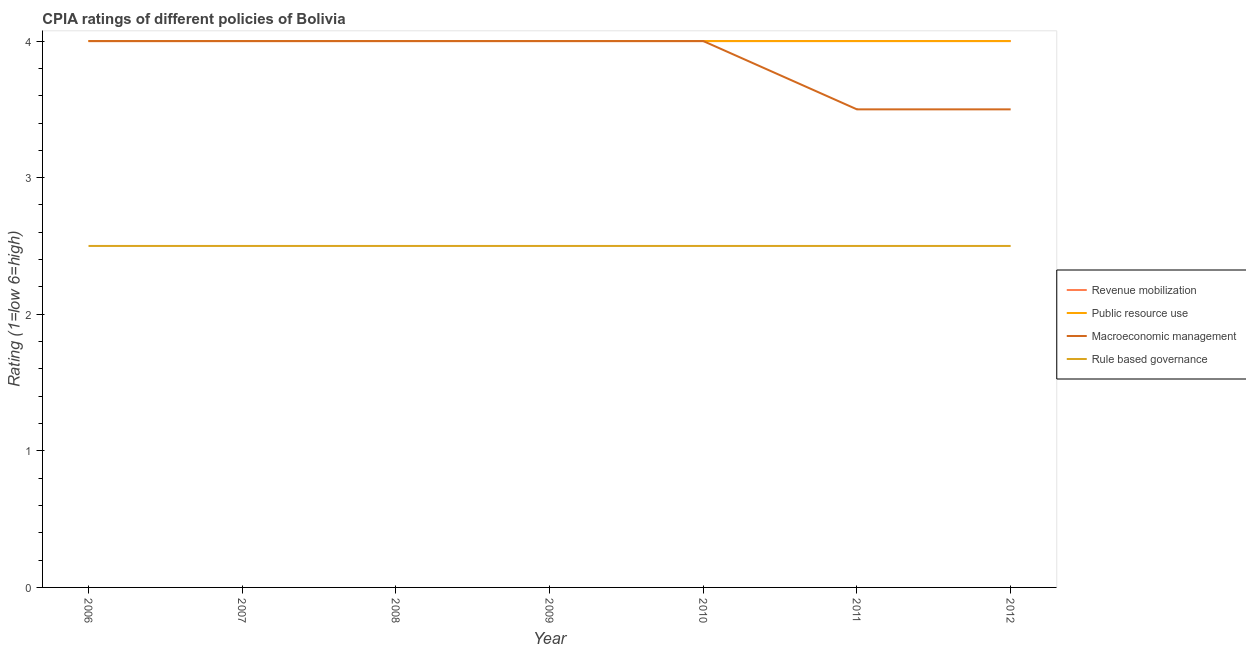How many different coloured lines are there?
Make the answer very short. 4. Is the number of lines equal to the number of legend labels?
Offer a terse response. Yes. Across all years, what is the maximum cpia rating of macroeconomic management?
Your answer should be very brief. 4. Across all years, what is the minimum cpia rating of public resource use?
Your response must be concise. 4. In which year was the cpia rating of public resource use maximum?
Provide a short and direct response. 2006. What is the average cpia rating of rule based governance per year?
Give a very brief answer. 2.5. What is the ratio of the cpia rating of macroeconomic management in 2010 to that in 2011?
Ensure brevity in your answer.  1.14. What is the difference between the highest and the second highest cpia rating of public resource use?
Your answer should be compact. 0. What is the difference between the highest and the lowest cpia rating of rule based governance?
Your response must be concise. 0. In how many years, is the cpia rating of public resource use greater than the average cpia rating of public resource use taken over all years?
Offer a very short reply. 0. Is the sum of the cpia rating of public resource use in 2009 and 2010 greater than the maximum cpia rating of rule based governance across all years?
Provide a succinct answer. Yes. Is it the case that in every year, the sum of the cpia rating of public resource use and cpia rating of macroeconomic management is greater than the sum of cpia rating of rule based governance and cpia rating of revenue mobilization?
Provide a succinct answer. No. Is the cpia rating of rule based governance strictly less than the cpia rating of public resource use over the years?
Your answer should be very brief. Yes. How many lines are there?
Offer a very short reply. 4. What is the difference between two consecutive major ticks on the Y-axis?
Your answer should be compact. 1. Does the graph contain any zero values?
Provide a short and direct response. No. How many legend labels are there?
Ensure brevity in your answer.  4. How are the legend labels stacked?
Keep it short and to the point. Vertical. What is the title of the graph?
Ensure brevity in your answer.  CPIA ratings of different policies of Bolivia. Does "Water" appear as one of the legend labels in the graph?
Provide a succinct answer. No. What is the label or title of the Y-axis?
Provide a short and direct response. Rating (1=low 6=high). What is the Rating (1=low 6=high) of Public resource use in 2006?
Make the answer very short. 4. What is the Rating (1=low 6=high) in Rule based governance in 2006?
Provide a short and direct response. 2.5. What is the Rating (1=low 6=high) of Revenue mobilization in 2007?
Provide a succinct answer. 4. What is the Rating (1=low 6=high) of Macroeconomic management in 2007?
Offer a very short reply. 4. What is the Rating (1=low 6=high) in Public resource use in 2008?
Ensure brevity in your answer.  4. What is the Rating (1=low 6=high) in Macroeconomic management in 2008?
Provide a succinct answer. 4. What is the Rating (1=low 6=high) of Revenue mobilization in 2009?
Your answer should be very brief. 4. What is the Rating (1=low 6=high) of Public resource use in 2009?
Provide a short and direct response. 4. What is the Rating (1=low 6=high) in Macroeconomic management in 2011?
Your response must be concise. 3.5. What is the Rating (1=low 6=high) in Rule based governance in 2011?
Your response must be concise. 2.5. What is the Rating (1=low 6=high) of Revenue mobilization in 2012?
Provide a succinct answer. 4. What is the Rating (1=low 6=high) of Rule based governance in 2012?
Provide a succinct answer. 2.5. Across all years, what is the maximum Rating (1=low 6=high) in Macroeconomic management?
Provide a short and direct response. 4. Across all years, what is the minimum Rating (1=low 6=high) of Revenue mobilization?
Offer a very short reply. 4. Across all years, what is the minimum Rating (1=low 6=high) in Public resource use?
Make the answer very short. 4. Across all years, what is the minimum Rating (1=low 6=high) in Macroeconomic management?
Keep it short and to the point. 3.5. What is the total Rating (1=low 6=high) of Macroeconomic management in the graph?
Your answer should be very brief. 27. What is the total Rating (1=low 6=high) of Rule based governance in the graph?
Provide a succinct answer. 17.5. What is the difference between the Rating (1=low 6=high) in Revenue mobilization in 2006 and that in 2007?
Ensure brevity in your answer.  0. What is the difference between the Rating (1=low 6=high) of Public resource use in 2006 and that in 2007?
Your answer should be very brief. 0. What is the difference between the Rating (1=low 6=high) in Macroeconomic management in 2006 and that in 2007?
Provide a succinct answer. 0. What is the difference between the Rating (1=low 6=high) in Revenue mobilization in 2006 and that in 2008?
Provide a succinct answer. 0. What is the difference between the Rating (1=low 6=high) in Rule based governance in 2006 and that in 2008?
Provide a short and direct response. 0. What is the difference between the Rating (1=low 6=high) in Rule based governance in 2006 and that in 2009?
Keep it short and to the point. 0. What is the difference between the Rating (1=low 6=high) in Macroeconomic management in 2006 and that in 2010?
Your answer should be compact. 0. What is the difference between the Rating (1=low 6=high) in Rule based governance in 2006 and that in 2010?
Your response must be concise. 0. What is the difference between the Rating (1=low 6=high) in Revenue mobilization in 2006 and that in 2011?
Your answer should be very brief. 0. What is the difference between the Rating (1=low 6=high) of Public resource use in 2006 and that in 2011?
Provide a succinct answer. 0. What is the difference between the Rating (1=low 6=high) in Macroeconomic management in 2006 and that in 2011?
Your answer should be compact. 0.5. What is the difference between the Rating (1=low 6=high) of Rule based governance in 2006 and that in 2011?
Give a very brief answer. 0. What is the difference between the Rating (1=low 6=high) in Revenue mobilization in 2006 and that in 2012?
Keep it short and to the point. 0. What is the difference between the Rating (1=low 6=high) of Public resource use in 2006 and that in 2012?
Your answer should be compact. 0. What is the difference between the Rating (1=low 6=high) in Macroeconomic management in 2006 and that in 2012?
Make the answer very short. 0.5. What is the difference between the Rating (1=low 6=high) of Macroeconomic management in 2007 and that in 2008?
Make the answer very short. 0. What is the difference between the Rating (1=low 6=high) of Macroeconomic management in 2007 and that in 2009?
Your response must be concise. 0. What is the difference between the Rating (1=low 6=high) in Revenue mobilization in 2007 and that in 2010?
Make the answer very short. 0. What is the difference between the Rating (1=low 6=high) in Rule based governance in 2007 and that in 2010?
Provide a short and direct response. 0. What is the difference between the Rating (1=low 6=high) in Revenue mobilization in 2007 and that in 2011?
Ensure brevity in your answer.  0. What is the difference between the Rating (1=low 6=high) of Public resource use in 2007 and that in 2011?
Provide a succinct answer. 0. What is the difference between the Rating (1=low 6=high) in Revenue mobilization in 2007 and that in 2012?
Make the answer very short. 0. What is the difference between the Rating (1=low 6=high) of Macroeconomic management in 2007 and that in 2012?
Provide a succinct answer. 0.5. What is the difference between the Rating (1=low 6=high) of Rule based governance in 2007 and that in 2012?
Provide a succinct answer. 0. What is the difference between the Rating (1=low 6=high) of Revenue mobilization in 2008 and that in 2009?
Your answer should be very brief. 0. What is the difference between the Rating (1=low 6=high) of Macroeconomic management in 2008 and that in 2009?
Keep it short and to the point. 0. What is the difference between the Rating (1=low 6=high) of Rule based governance in 2008 and that in 2009?
Give a very brief answer. 0. What is the difference between the Rating (1=low 6=high) in Macroeconomic management in 2008 and that in 2010?
Your response must be concise. 0. What is the difference between the Rating (1=low 6=high) in Rule based governance in 2008 and that in 2010?
Give a very brief answer. 0. What is the difference between the Rating (1=low 6=high) in Revenue mobilization in 2008 and that in 2011?
Provide a succinct answer. 0. What is the difference between the Rating (1=low 6=high) of Public resource use in 2008 and that in 2011?
Offer a terse response. 0. What is the difference between the Rating (1=low 6=high) in Macroeconomic management in 2008 and that in 2011?
Your answer should be compact. 0.5. What is the difference between the Rating (1=low 6=high) of Rule based governance in 2008 and that in 2011?
Make the answer very short. 0. What is the difference between the Rating (1=low 6=high) in Revenue mobilization in 2008 and that in 2012?
Give a very brief answer. 0. What is the difference between the Rating (1=low 6=high) in Public resource use in 2008 and that in 2012?
Make the answer very short. 0. What is the difference between the Rating (1=low 6=high) in Macroeconomic management in 2008 and that in 2012?
Your response must be concise. 0.5. What is the difference between the Rating (1=low 6=high) of Macroeconomic management in 2009 and that in 2010?
Provide a short and direct response. 0. What is the difference between the Rating (1=low 6=high) in Rule based governance in 2009 and that in 2010?
Provide a short and direct response. 0. What is the difference between the Rating (1=low 6=high) of Revenue mobilization in 2009 and that in 2011?
Your answer should be compact. 0. What is the difference between the Rating (1=low 6=high) in Macroeconomic management in 2009 and that in 2011?
Your answer should be compact. 0.5. What is the difference between the Rating (1=low 6=high) of Rule based governance in 2009 and that in 2011?
Your answer should be very brief. 0. What is the difference between the Rating (1=low 6=high) in Revenue mobilization in 2009 and that in 2012?
Ensure brevity in your answer.  0. What is the difference between the Rating (1=low 6=high) in Macroeconomic management in 2009 and that in 2012?
Offer a terse response. 0.5. What is the difference between the Rating (1=low 6=high) of Rule based governance in 2009 and that in 2012?
Offer a very short reply. 0. What is the difference between the Rating (1=low 6=high) of Macroeconomic management in 2010 and that in 2011?
Provide a succinct answer. 0.5. What is the difference between the Rating (1=low 6=high) of Macroeconomic management in 2010 and that in 2012?
Your response must be concise. 0.5. What is the difference between the Rating (1=low 6=high) in Public resource use in 2011 and that in 2012?
Offer a very short reply. 0. What is the difference between the Rating (1=low 6=high) of Rule based governance in 2011 and that in 2012?
Make the answer very short. 0. What is the difference between the Rating (1=low 6=high) of Public resource use in 2006 and the Rating (1=low 6=high) of Macroeconomic management in 2007?
Provide a succinct answer. 0. What is the difference between the Rating (1=low 6=high) in Revenue mobilization in 2006 and the Rating (1=low 6=high) in Public resource use in 2008?
Make the answer very short. 0. What is the difference between the Rating (1=low 6=high) in Revenue mobilization in 2006 and the Rating (1=low 6=high) in Macroeconomic management in 2008?
Offer a terse response. 0. What is the difference between the Rating (1=low 6=high) of Revenue mobilization in 2006 and the Rating (1=low 6=high) of Rule based governance in 2008?
Offer a very short reply. 1.5. What is the difference between the Rating (1=low 6=high) of Public resource use in 2006 and the Rating (1=low 6=high) of Macroeconomic management in 2008?
Your answer should be very brief. 0. What is the difference between the Rating (1=low 6=high) in Public resource use in 2006 and the Rating (1=low 6=high) in Rule based governance in 2008?
Make the answer very short. 1.5. What is the difference between the Rating (1=low 6=high) of Revenue mobilization in 2006 and the Rating (1=low 6=high) of Public resource use in 2009?
Offer a very short reply. 0. What is the difference between the Rating (1=low 6=high) in Revenue mobilization in 2006 and the Rating (1=low 6=high) in Rule based governance in 2009?
Your answer should be very brief. 1.5. What is the difference between the Rating (1=low 6=high) in Public resource use in 2006 and the Rating (1=low 6=high) in Rule based governance in 2009?
Provide a short and direct response. 1.5. What is the difference between the Rating (1=low 6=high) in Revenue mobilization in 2006 and the Rating (1=low 6=high) in Macroeconomic management in 2010?
Provide a short and direct response. 0. What is the difference between the Rating (1=low 6=high) of Public resource use in 2006 and the Rating (1=low 6=high) of Macroeconomic management in 2010?
Give a very brief answer. 0. What is the difference between the Rating (1=low 6=high) in Public resource use in 2006 and the Rating (1=low 6=high) in Rule based governance in 2010?
Ensure brevity in your answer.  1.5. What is the difference between the Rating (1=low 6=high) in Macroeconomic management in 2006 and the Rating (1=low 6=high) in Rule based governance in 2010?
Your answer should be very brief. 1.5. What is the difference between the Rating (1=low 6=high) in Revenue mobilization in 2006 and the Rating (1=low 6=high) in Public resource use in 2011?
Your response must be concise. 0. What is the difference between the Rating (1=low 6=high) in Revenue mobilization in 2006 and the Rating (1=low 6=high) in Rule based governance in 2011?
Offer a very short reply. 1.5. What is the difference between the Rating (1=low 6=high) in Public resource use in 2006 and the Rating (1=low 6=high) in Macroeconomic management in 2011?
Keep it short and to the point. 0.5. What is the difference between the Rating (1=low 6=high) in Macroeconomic management in 2006 and the Rating (1=low 6=high) in Rule based governance in 2011?
Provide a short and direct response. 1.5. What is the difference between the Rating (1=low 6=high) of Revenue mobilization in 2006 and the Rating (1=low 6=high) of Rule based governance in 2012?
Ensure brevity in your answer.  1.5. What is the difference between the Rating (1=low 6=high) in Public resource use in 2006 and the Rating (1=low 6=high) in Macroeconomic management in 2012?
Keep it short and to the point. 0.5. What is the difference between the Rating (1=low 6=high) of Public resource use in 2006 and the Rating (1=low 6=high) of Rule based governance in 2012?
Your response must be concise. 1.5. What is the difference between the Rating (1=low 6=high) of Revenue mobilization in 2007 and the Rating (1=low 6=high) of Public resource use in 2008?
Provide a short and direct response. 0. What is the difference between the Rating (1=low 6=high) in Revenue mobilization in 2007 and the Rating (1=low 6=high) in Macroeconomic management in 2008?
Keep it short and to the point. 0. What is the difference between the Rating (1=low 6=high) in Revenue mobilization in 2007 and the Rating (1=low 6=high) in Rule based governance in 2008?
Offer a very short reply. 1.5. What is the difference between the Rating (1=low 6=high) of Macroeconomic management in 2007 and the Rating (1=low 6=high) of Rule based governance in 2008?
Offer a very short reply. 1.5. What is the difference between the Rating (1=low 6=high) of Revenue mobilization in 2007 and the Rating (1=low 6=high) of Rule based governance in 2009?
Provide a short and direct response. 1.5. What is the difference between the Rating (1=low 6=high) in Public resource use in 2007 and the Rating (1=low 6=high) in Macroeconomic management in 2009?
Provide a succinct answer. 0. What is the difference between the Rating (1=low 6=high) of Macroeconomic management in 2007 and the Rating (1=low 6=high) of Rule based governance in 2009?
Ensure brevity in your answer.  1.5. What is the difference between the Rating (1=low 6=high) of Revenue mobilization in 2007 and the Rating (1=low 6=high) of Macroeconomic management in 2010?
Keep it short and to the point. 0. What is the difference between the Rating (1=low 6=high) in Revenue mobilization in 2007 and the Rating (1=low 6=high) in Rule based governance in 2010?
Make the answer very short. 1.5. What is the difference between the Rating (1=low 6=high) of Public resource use in 2007 and the Rating (1=low 6=high) of Macroeconomic management in 2010?
Provide a succinct answer. 0. What is the difference between the Rating (1=low 6=high) of Public resource use in 2007 and the Rating (1=low 6=high) of Rule based governance in 2010?
Provide a succinct answer. 1.5. What is the difference between the Rating (1=low 6=high) of Revenue mobilization in 2007 and the Rating (1=low 6=high) of Macroeconomic management in 2011?
Provide a short and direct response. 0.5. What is the difference between the Rating (1=low 6=high) in Public resource use in 2007 and the Rating (1=low 6=high) in Macroeconomic management in 2011?
Provide a short and direct response. 0.5. What is the difference between the Rating (1=low 6=high) in Public resource use in 2007 and the Rating (1=low 6=high) in Rule based governance in 2012?
Make the answer very short. 1.5. What is the difference between the Rating (1=low 6=high) of Revenue mobilization in 2008 and the Rating (1=low 6=high) of Public resource use in 2009?
Make the answer very short. 0. What is the difference between the Rating (1=low 6=high) of Revenue mobilization in 2008 and the Rating (1=low 6=high) of Macroeconomic management in 2009?
Your answer should be very brief. 0. What is the difference between the Rating (1=low 6=high) in Revenue mobilization in 2008 and the Rating (1=low 6=high) in Rule based governance in 2009?
Keep it short and to the point. 1.5. What is the difference between the Rating (1=low 6=high) in Public resource use in 2008 and the Rating (1=low 6=high) in Macroeconomic management in 2009?
Offer a terse response. 0. What is the difference between the Rating (1=low 6=high) in Public resource use in 2008 and the Rating (1=low 6=high) in Rule based governance in 2009?
Ensure brevity in your answer.  1.5. What is the difference between the Rating (1=low 6=high) of Macroeconomic management in 2008 and the Rating (1=low 6=high) of Rule based governance in 2009?
Keep it short and to the point. 1.5. What is the difference between the Rating (1=low 6=high) in Revenue mobilization in 2008 and the Rating (1=low 6=high) in Public resource use in 2010?
Keep it short and to the point. 0. What is the difference between the Rating (1=low 6=high) in Public resource use in 2008 and the Rating (1=low 6=high) in Macroeconomic management in 2010?
Offer a terse response. 0. What is the difference between the Rating (1=low 6=high) in Public resource use in 2008 and the Rating (1=low 6=high) in Rule based governance in 2010?
Make the answer very short. 1.5. What is the difference between the Rating (1=low 6=high) in Macroeconomic management in 2008 and the Rating (1=low 6=high) in Rule based governance in 2011?
Provide a succinct answer. 1.5. What is the difference between the Rating (1=low 6=high) in Public resource use in 2008 and the Rating (1=low 6=high) in Macroeconomic management in 2012?
Give a very brief answer. 0.5. What is the difference between the Rating (1=low 6=high) in Public resource use in 2008 and the Rating (1=low 6=high) in Rule based governance in 2012?
Provide a short and direct response. 1.5. What is the difference between the Rating (1=low 6=high) of Macroeconomic management in 2008 and the Rating (1=low 6=high) of Rule based governance in 2012?
Keep it short and to the point. 1.5. What is the difference between the Rating (1=low 6=high) in Revenue mobilization in 2009 and the Rating (1=low 6=high) in Rule based governance in 2010?
Offer a terse response. 1.5. What is the difference between the Rating (1=low 6=high) of Public resource use in 2009 and the Rating (1=low 6=high) of Macroeconomic management in 2010?
Offer a very short reply. 0. What is the difference between the Rating (1=low 6=high) of Public resource use in 2009 and the Rating (1=low 6=high) of Rule based governance in 2010?
Keep it short and to the point. 1.5. What is the difference between the Rating (1=low 6=high) in Revenue mobilization in 2009 and the Rating (1=low 6=high) in Public resource use in 2011?
Keep it short and to the point. 0. What is the difference between the Rating (1=low 6=high) of Public resource use in 2009 and the Rating (1=low 6=high) of Macroeconomic management in 2011?
Provide a succinct answer. 0.5. What is the difference between the Rating (1=low 6=high) of Public resource use in 2009 and the Rating (1=low 6=high) of Macroeconomic management in 2012?
Your answer should be compact. 0.5. What is the difference between the Rating (1=low 6=high) in Macroeconomic management in 2009 and the Rating (1=low 6=high) in Rule based governance in 2012?
Offer a very short reply. 1.5. What is the difference between the Rating (1=low 6=high) in Public resource use in 2010 and the Rating (1=low 6=high) in Rule based governance in 2011?
Provide a short and direct response. 1.5. What is the difference between the Rating (1=low 6=high) of Macroeconomic management in 2010 and the Rating (1=low 6=high) of Rule based governance in 2011?
Offer a terse response. 1.5. What is the difference between the Rating (1=low 6=high) of Revenue mobilization in 2010 and the Rating (1=low 6=high) of Rule based governance in 2012?
Offer a very short reply. 1.5. What is the difference between the Rating (1=low 6=high) of Public resource use in 2010 and the Rating (1=low 6=high) of Macroeconomic management in 2012?
Your response must be concise. 0.5. What is the difference between the Rating (1=low 6=high) of Public resource use in 2010 and the Rating (1=low 6=high) of Rule based governance in 2012?
Offer a very short reply. 1.5. What is the difference between the Rating (1=low 6=high) in Revenue mobilization in 2011 and the Rating (1=low 6=high) in Public resource use in 2012?
Your answer should be very brief. 0. What is the difference between the Rating (1=low 6=high) in Revenue mobilization in 2011 and the Rating (1=low 6=high) in Macroeconomic management in 2012?
Provide a succinct answer. 0.5. What is the difference between the Rating (1=low 6=high) in Public resource use in 2011 and the Rating (1=low 6=high) in Rule based governance in 2012?
Offer a terse response. 1.5. What is the average Rating (1=low 6=high) of Public resource use per year?
Offer a terse response. 4. What is the average Rating (1=low 6=high) of Macroeconomic management per year?
Give a very brief answer. 3.86. What is the average Rating (1=low 6=high) in Rule based governance per year?
Your response must be concise. 2.5. In the year 2006, what is the difference between the Rating (1=low 6=high) of Macroeconomic management and Rating (1=low 6=high) of Rule based governance?
Your answer should be very brief. 1.5. In the year 2007, what is the difference between the Rating (1=low 6=high) in Revenue mobilization and Rating (1=low 6=high) in Macroeconomic management?
Give a very brief answer. 0. In the year 2007, what is the difference between the Rating (1=low 6=high) of Revenue mobilization and Rating (1=low 6=high) of Rule based governance?
Offer a very short reply. 1.5. In the year 2007, what is the difference between the Rating (1=low 6=high) of Macroeconomic management and Rating (1=low 6=high) of Rule based governance?
Keep it short and to the point. 1.5. In the year 2008, what is the difference between the Rating (1=low 6=high) of Public resource use and Rating (1=low 6=high) of Macroeconomic management?
Provide a short and direct response. 0. In the year 2009, what is the difference between the Rating (1=low 6=high) in Revenue mobilization and Rating (1=low 6=high) in Public resource use?
Give a very brief answer. 0. In the year 2009, what is the difference between the Rating (1=low 6=high) of Revenue mobilization and Rating (1=low 6=high) of Macroeconomic management?
Offer a very short reply. 0. In the year 2009, what is the difference between the Rating (1=low 6=high) of Public resource use and Rating (1=low 6=high) of Macroeconomic management?
Offer a terse response. 0. In the year 2010, what is the difference between the Rating (1=low 6=high) in Revenue mobilization and Rating (1=low 6=high) in Rule based governance?
Offer a very short reply. 1.5. In the year 2010, what is the difference between the Rating (1=low 6=high) in Public resource use and Rating (1=low 6=high) in Rule based governance?
Make the answer very short. 1.5. In the year 2011, what is the difference between the Rating (1=low 6=high) in Revenue mobilization and Rating (1=low 6=high) in Macroeconomic management?
Offer a very short reply. 0.5. In the year 2011, what is the difference between the Rating (1=low 6=high) in Revenue mobilization and Rating (1=low 6=high) in Rule based governance?
Ensure brevity in your answer.  1.5. In the year 2011, what is the difference between the Rating (1=low 6=high) of Public resource use and Rating (1=low 6=high) of Macroeconomic management?
Your answer should be very brief. 0.5. In the year 2011, what is the difference between the Rating (1=low 6=high) of Public resource use and Rating (1=low 6=high) of Rule based governance?
Ensure brevity in your answer.  1.5. In the year 2012, what is the difference between the Rating (1=low 6=high) of Revenue mobilization and Rating (1=low 6=high) of Public resource use?
Your answer should be compact. 0. In the year 2012, what is the difference between the Rating (1=low 6=high) in Revenue mobilization and Rating (1=low 6=high) in Macroeconomic management?
Provide a short and direct response. 0.5. In the year 2012, what is the difference between the Rating (1=low 6=high) of Public resource use and Rating (1=low 6=high) of Macroeconomic management?
Give a very brief answer. 0.5. In the year 2012, what is the difference between the Rating (1=low 6=high) of Macroeconomic management and Rating (1=low 6=high) of Rule based governance?
Your response must be concise. 1. What is the ratio of the Rating (1=low 6=high) in Public resource use in 2006 to that in 2007?
Ensure brevity in your answer.  1. What is the ratio of the Rating (1=low 6=high) in Macroeconomic management in 2006 to that in 2007?
Offer a very short reply. 1. What is the ratio of the Rating (1=low 6=high) in Rule based governance in 2006 to that in 2007?
Ensure brevity in your answer.  1. What is the ratio of the Rating (1=low 6=high) of Revenue mobilization in 2006 to that in 2008?
Your response must be concise. 1. What is the ratio of the Rating (1=low 6=high) in Public resource use in 2006 to that in 2008?
Keep it short and to the point. 1. What is the ratio of the Rating (1=low 6=high) in Macroeconomic management in 2006 to that in 2008?
Give a very brief answer. 1. What is the ratio of the Rating (1=low 6=high) of Revenue mobilization in 2006 to that in 2009?
Your response must be concise. 1. What is the ratio of the Rating (1=low 6=high) of Revenue mobilization in 2006 to that in 2010?
Offer a terse response. 1. What is the ratio of the Rating (1=low 6=high) of Rule based governance in 2006 to that in 2010?
Provide a succinct answer. 1. What is the ratio of the Rating (1=low 6=high) in Revenue mobilization in 2006 to that in 2011?
Offer a very short reply. 1. What is the ratio of the Rating (1=low 6=high) of Public resource use in 2006 to that in 2011?
Offer a very short reply. 1. What is the ratio of the Rating (1=low 6=high) in Rule based governance in 2006 to that in 2011?
Your answer should be very brief. 1. What is the ratio of the Rating (1=low 6=high) of Revenue mobilization in 2007 to that in 2008?
Offer a very short reply. 1. What is the ratio of the Rating (1=low 6=high) in Public resource use in 2007 to that in 2009?
Keep it short and to the point. 1. What is the ratio of the Rating (1=low 6=high) in Macroeconomic management in 2007 to that in 2009?
Offer a terse response. 1. What is the ratio of the Rating (1=low 6=high) of Revenue mobilization in 2007 to that in 2010?
Offer a terse response. 1. What is the ratio of the Rating (1=low 6=high) in Public resource use in 2007 to that in 2010?
Provide a short and direct response. 1. What is the ratio of the Rating (1=low 6=high) in Rule based governance in 2007 to that in 2010?
Give a very brief answer. 1. What is the ratio of the Rating (1=low 6=high) in Public resource use in 2007 to that in 2011?
Your answer should be very brief. 1. What is the ratio of the Rating (1=low 6=high) of Revenue mobilization in 2007 to that in 2012?
Provide a succinct answer. 1. What is the ratio of the Rating (1=low 6=high) in Macroeconomic management in 2007 to that in 2012?
Offer a very short reply. 1.14. What is the ratio of the Rating (1=low 6=high) of Rule based governance in 2007 to that in 2012?
Give a very brief answer. 1. What is the ratio of the Rating (1=low 6=high) in Revenue mobilization in 2008 to that in 2009?
Your answer should be compact. 1. What is the ratio of the Rating (1=low 6=high) in Public resource use in 2008 to that in 2009?
Make the answer very short. 1. What is the ratio of the Rating (1=low 6=high) of Macroeconomic management in 2008 to that in 2009?
Offer a very short reply. 1. What is the ratio of the Rating (1=low 6=high) in Public resource use in 2008 to that in 2010?
Your response must be concise. 1. What is the ratio of the Rating (1=low 6=high) in Rule based governance in 2008 to that in 2010?
Offer a very short reply. 1. What is the ratio of the Rating (1=low 6=high) in Public resource use in 2008 to that in 2011?
Offer a very short reply. 1. What is the ratio of the Rating (1=low 6=high) of Macroeconomic management in 2008 to that in 2011?
Offer a terse response. 1.14. What is the ratio of the Rating (1=low 6=high) of Macroeconomic management in 2008 to that in 2012?
Keep it short and to the point. 1.14. What is the ratio of the Rating (1=low 6=high) of Public resource use in 2009 to that in 2010?
Your answer should be very brief. 1. What is the ratio of the Rating (1=low 6=high) of Macroeconomic management in 2009 to that in 2010?
Give a very brief answer. 1. What is the ratio of the Rating (1=low 6=high) of Revenue mobilization in 2009 to that in 2011?
Ensure brevity in your answer.  1. What is the ratio of the Rating (1=low 6=high) in Public resource use in 2009 to that in 2011?
Provide a succinct answer. 1. What is the ratio of the Rating (1=low 6=high) in Macroeconomic management in 2009 to that in 2011?
Give a very brief answer. 1.14. What is the ratio of the Rating (1=low 6=high) of Revenue mobilization in 2009 to that in 2012?
Keep it short and to the point. 1. What is the ratio of the Rating (1=low 6=high) in Rule based governance in 2009 to that in 2012?
Make the answer very short. 1. What is the ratio of the Rating (1=low 6=high) of Public resource use in 2010 to that in 2011?
Provide a succinct answer. 1. What is the ratio of the Rating (1=low 6=high) in Macroeconomic management in 2010 to that in 2011?
Your response must be concise. 1.14. What is the ratio of the Rating (1=low 6=high) in Rule based governance in 2010 to that in 2011?
Give a very brief answer. 1. What is the ratio of the Rating (1=low 6=high) of Revenue mobilization in 2010 to that in 2012?
Provide a succinct answer. 1. What is the ratio of the Rating (1=low 6=high) of Macroeconomic management in 2010 to that in 2012?
Ensure brevity in your answer.  1.14. What is the ratio of the Rating (1=low 6=high) in Macroeconomic management in 2011 to that in 2012?
Give a very brief answer. 1. What is the difference between the highest and the second highest Rating (1=low 6=high) of Revenue mobilization?
Your response must be concise. 0. What is the difference between the highest and the second highest Rating (1=low 6=high) of Public resource use?
Provide a short and direct response. 0. What is the difference between the highest and the second highest Rating (1=low 6=high) in Rule based governance?
Your response must be concise. 0. What is the difference between the highest and the lowest Rating (1=low 6=high) in Macroeconomic management?
Offer a terse response. 0.5. What is the difference between the highest and the lowest Rating (1=low 6=high) in Rule based governance?
Keep it short and to the point. 0. 